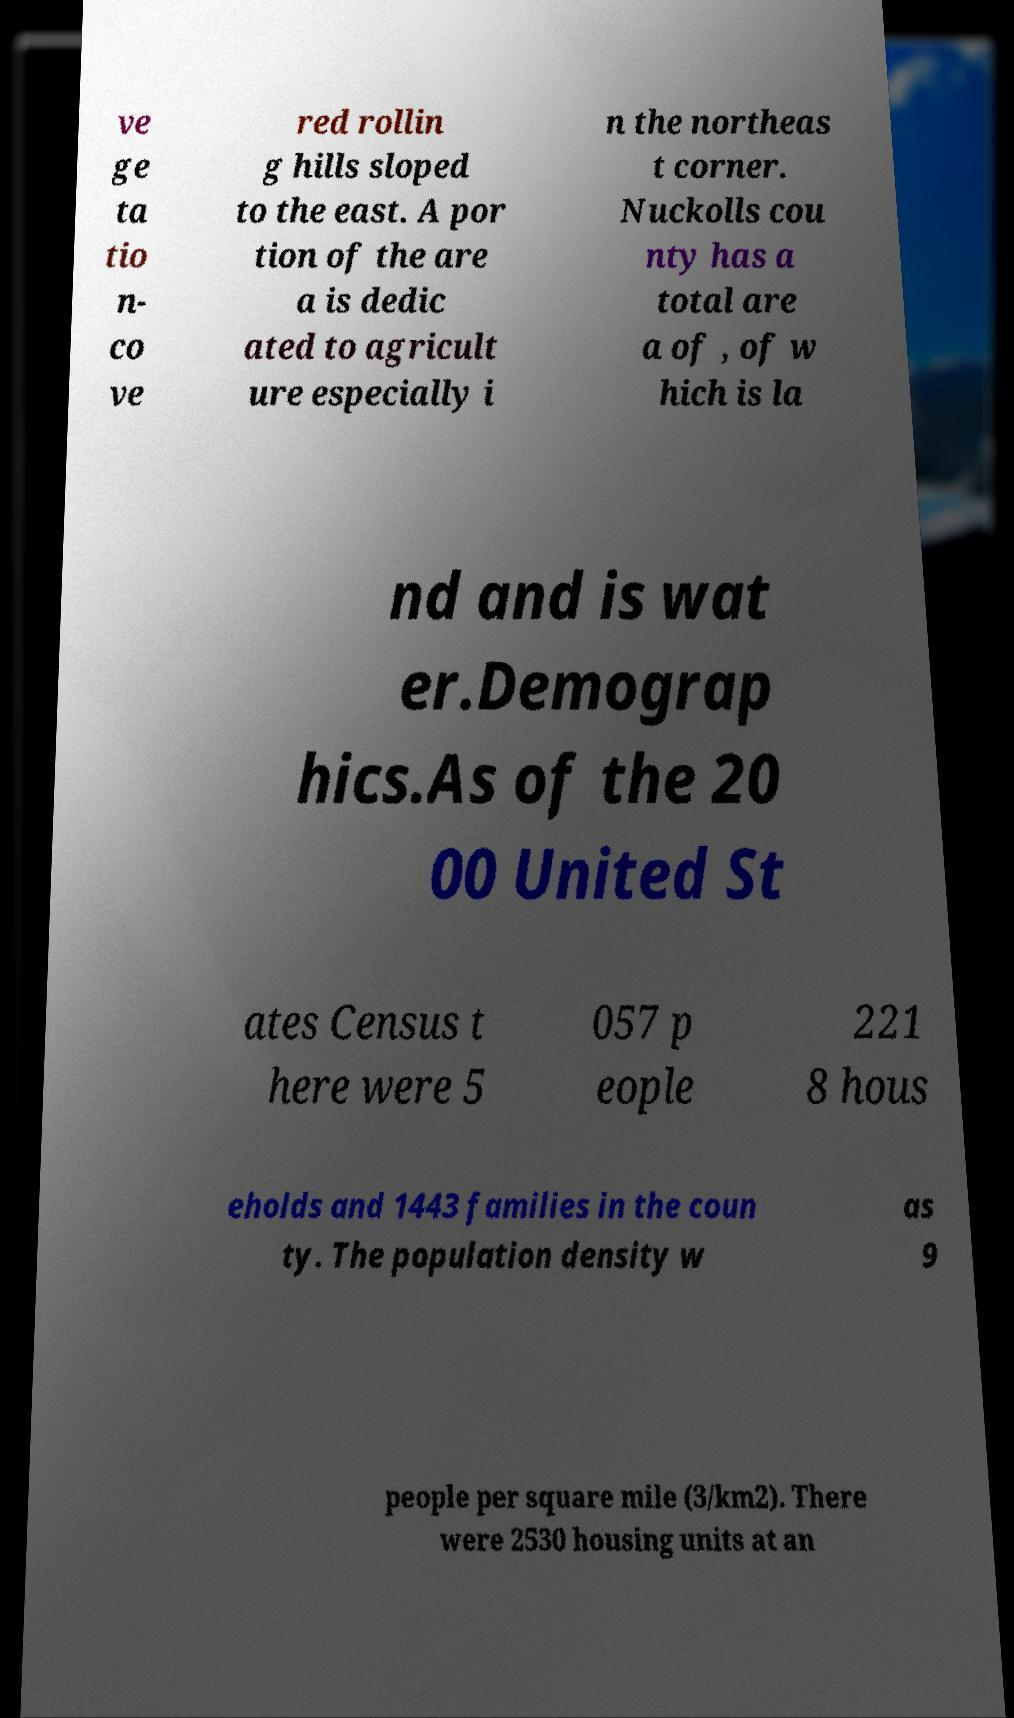Can you accurately transcribe the text from the provided image for me? ve ge ta tio n- co ve red rollin g hills sloped to the east. A por tion of the are a is dedic ated to agricult ure especially i n the northeas t corner. Nuckolls cou nty has a total are a of , of w hich is la nd and is wat er.Demograp hics.As of the 20 00 United St ates Census t here were 5 057 p eople 221 8 hous eholds and 1443 families in the coun ty. The population density w as 9 people per square mile (3/km2). There were 2530 housing units at an 